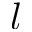Convert formula to latex. <formula><loc_0><loc_0><loc_500><loc_500>l</formula> 